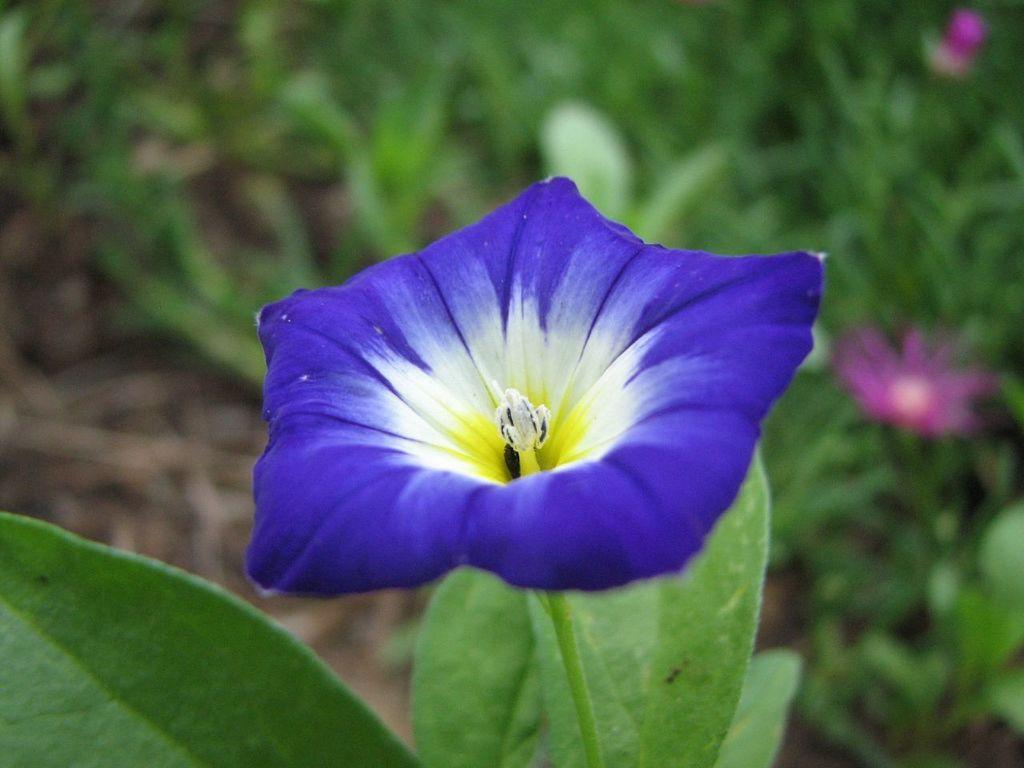What can be seen in the foreground of the picture? There are leaves and a flower in the foreground of the picture. How would you describe the background of the image? The background of the image is blurred. What types of plants are visible in the background of the image? There are plants and flowers in the background of the image. What type of guitar is being played by the farmer in the background of the image? There is no farmer or guitar present in the image; it features leaves, a flower, and a blurred background with plants and flowers. 